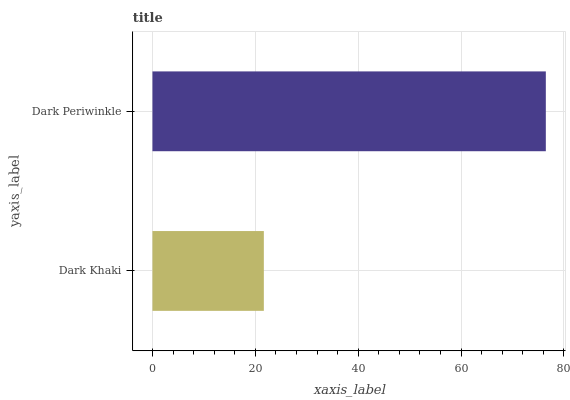Is Dark Khaki the minimum?
Answer yes or no. Yes. Is Dark Periwinkle the maximum?
Answer yes or no. Yes. Is Dark Periwinkle the minimum?
Answer yes or no. No. Is Dark Periwinkle greater than Dark Khaki?
Answer yes or no. Yes. Is Dark Khaki less than Dark Periwinkle?
Answer yes or no. Yes. Is Dark Khaki greater than Dark Periwinkle?
Answer yes or no. No. Is Dark Periwinkle less than Dark Khaki?
Answer yes or no. No. Is Dark Periwinkle the high median?
Answer yes or no. Yes. Is Dark Khaki the low median?
Answer yes or no. Yes. Is Dark Khaki the high median?
Answer yes or no. No. Is Dark Periwinkle the low median?
Answer yes or no. No. 